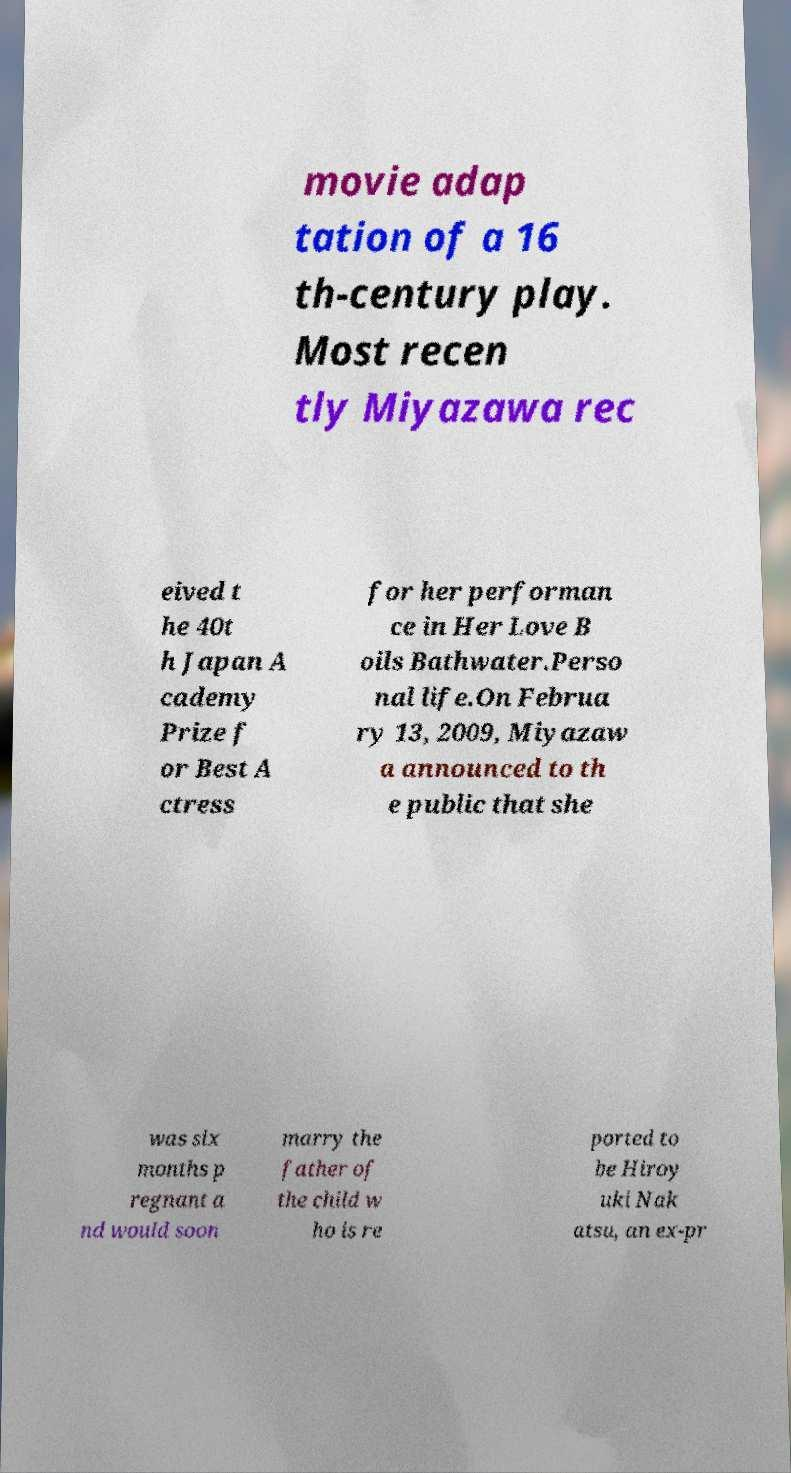Could you extract and type out the text from this image? movie adap tation of a 16 th-century play. Most recen tly Miyazawa rec eived t he 40t h Japan A cademy Prize f or Best A ctress for her performan ce in Her Love B oils Bathwater.Perso nal life.On Februa ry 13, 2009, Miyazaw a announced to th e public that she was six months p regnant a nd would soon marry the father of the child w ho is re ported to be Hiroy uki Nak atsu, an ex-pr 